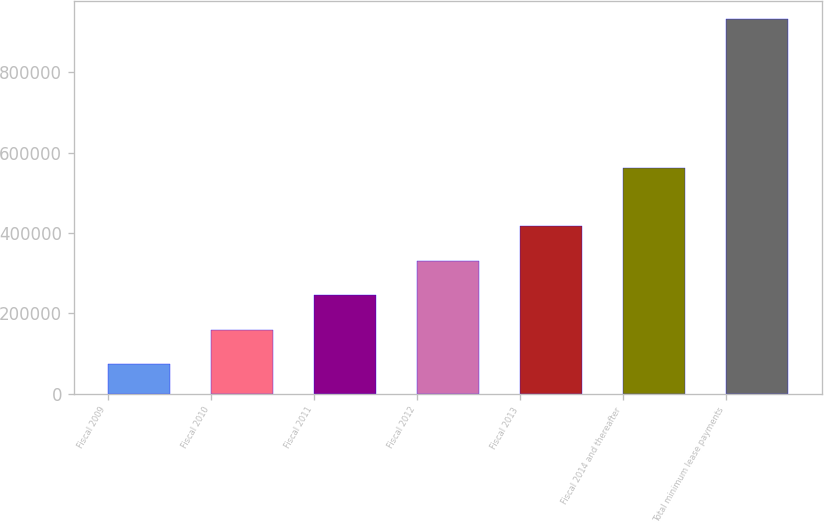<chart> <loc_0><loc_0><loc_500><loc_500><bar_chart><fcel>Fiscal 2009<fcel>Fiscal 2010<fcel>Fiscal 2011<fcel>Fiscal 2012<fcel>Fiscal 2013<fcel>Fiscal 2014 and thereafter<fcel>Total minimum lease payments<nl><fcel>73542<fcel>159361<fcel>245180<fcel>330999<fcel>416818<fcel>561040<fcel>931732<nl></chart> 